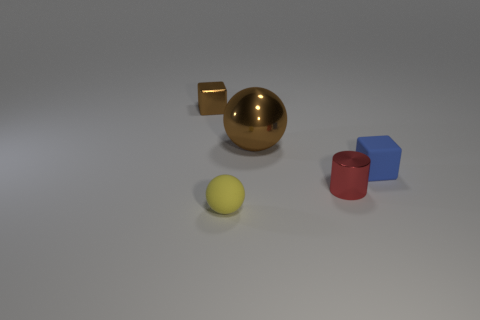Add 5 small cyan rubber things. How many objects exist? 10 Subtract all cylinders. How many objects are left? 4 Subtract 0 green blocks. How many objects are left? 5 Subtract all brown metallic balls. Subtract all matte spheres. How many objects are left? 3 Add 4 large brown shiny objects. How many large brown shiny objects are left? 5 Add 1 blue metallic cylinders. How many blue metallic cylinders exist? 1 